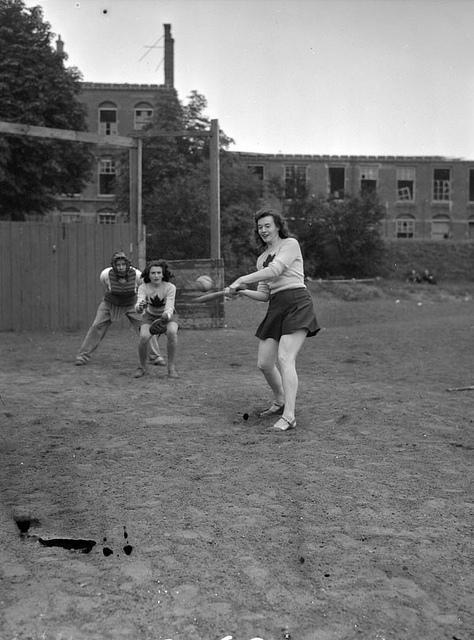How many shrubs are in this picture?
Give a very brief answer. 3. How many people are in the picture?
Give a very brief answer. 3. How many vases have flowers in them?
Give a very brief answer. 0. 